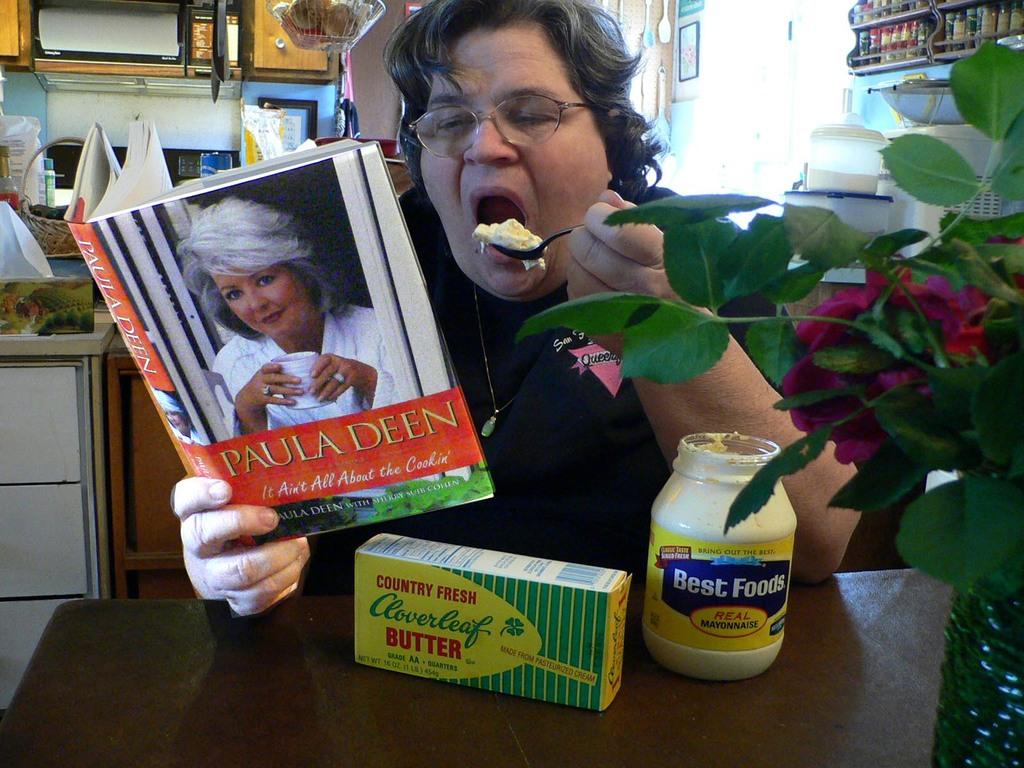What brand of butter is on the table?
Your answer should be very brief. Cloverleaf. 